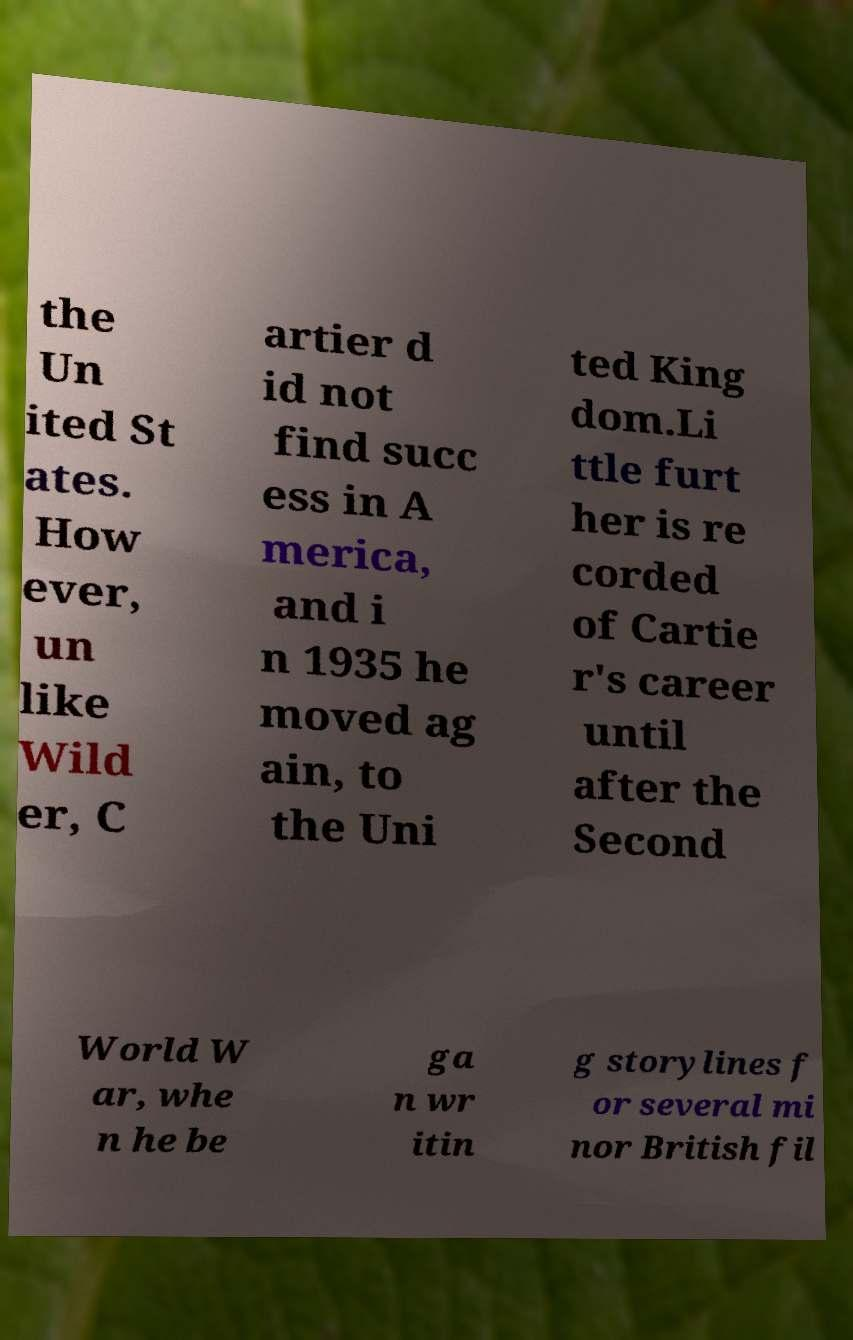Could you assist in decoding the text presented in this image and type it out clearly? the Un ited St ates. How ever, un like Wild er, C artier d id not find succ ess in A merica, and i n 1935 he moved ag ain, to the Uni ted King dom.Li ttle furt her is re corded of Cartie r's career until after the Second World W ar, whe n he be ga n wr itin g storylines f or several mi nor British fil 